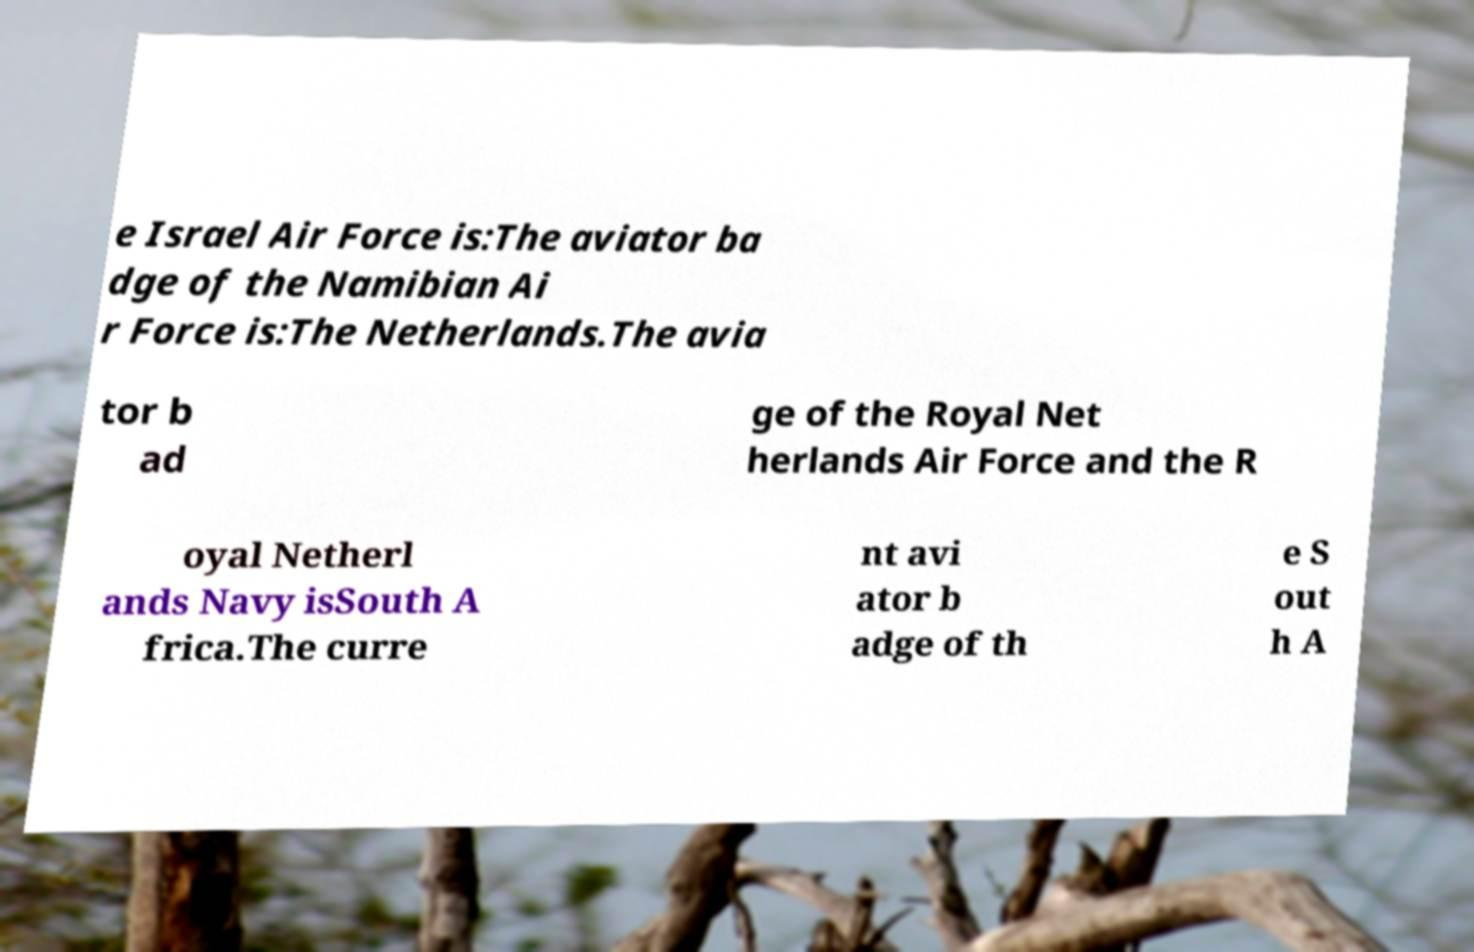Please identify and transcribe the text found in this image. e Israel Air Force is:The aviator ba dge of the Namibian Ai r Force is:The Netherlands.The avia tor b ad ge of the Royal Net herlands Air Force and the R oyal Netherl ands Navy isSouth A frica.The curre nt avi ator b adge of th e S out h A 